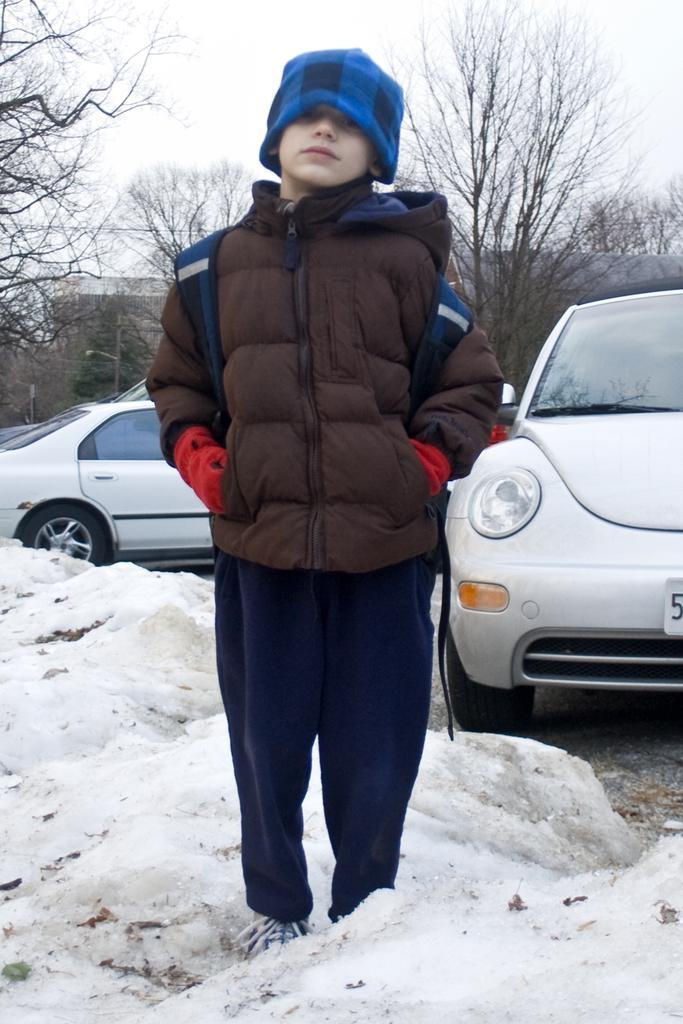Describe this image in one or two sentences. In this image we can see a child standing on the ground which is covered with snow. On the backside we can see some cars parked on the ground, a group of trees, a building and the sky which looks cloudy. 